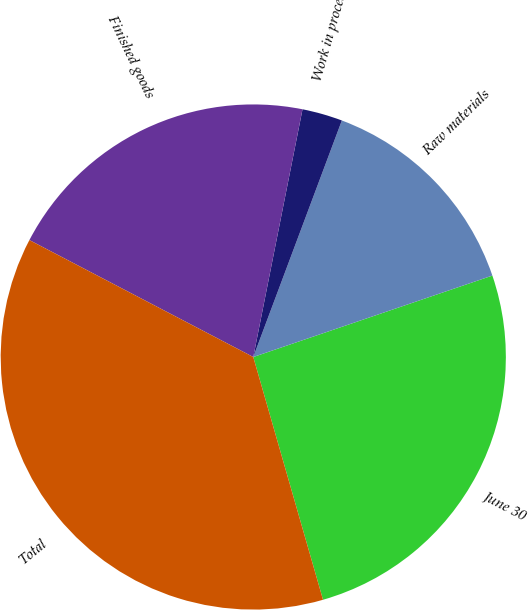<chart> <loc_0><loc_0><loc_500><loc_500><pie_chart><fcel>June 30<fcel>Raw materials<fcel>Work in process<fcel>Finished goods<fcel>Total<nl><fcel>25.77%<fcel>14.07%<fcel>2.58%<fcel>20.46%<fcel>37.11%<nl></chart> 